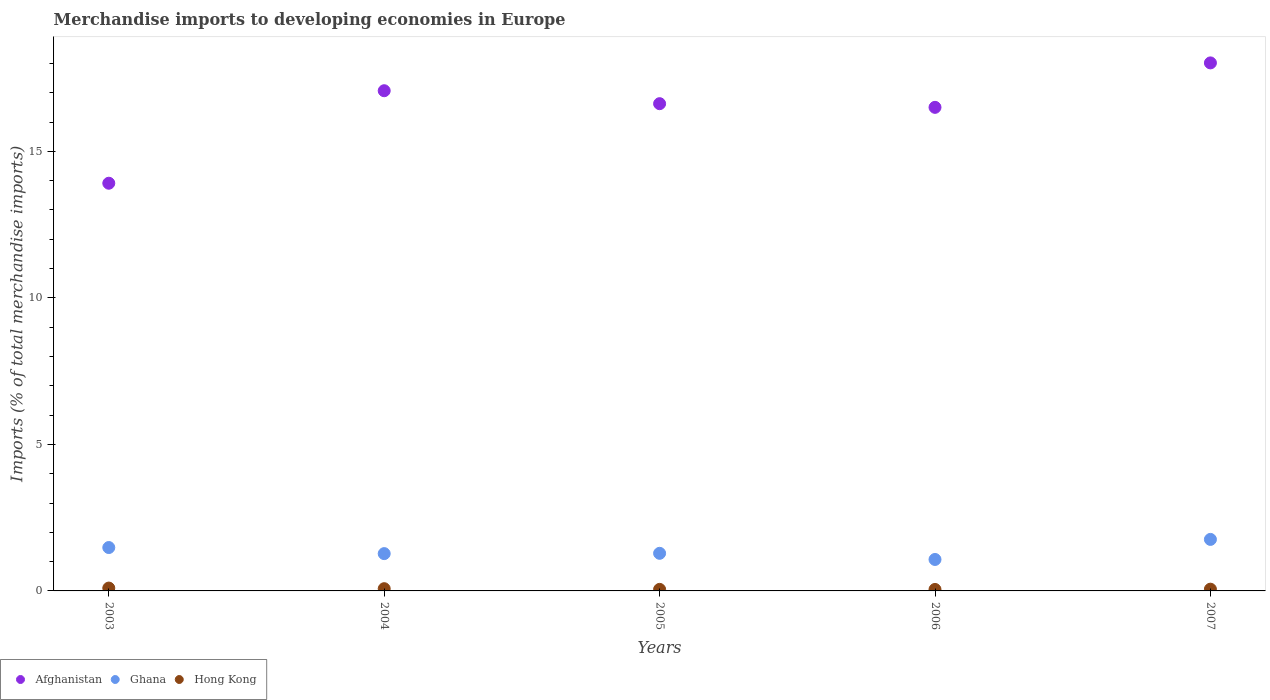Is the number of dotlines equal to the number of legend labels?
Give a very brief answer. Yes. What is the percentage total merchandise imports in Hong Kong in 2006?
Provide a succinct answer. 0.05. Across all years, what is the maximum percentage total merchandise imports in Afghanistan?
Ensure brevity in your answer.  18.02. Across all years, what is the minimum percentage total merchandise imports in Ghana?
Make the answer very short. 1.07. What is the total percentage total merchandise imports in Ghana in the graph?
Provide a succinct answer. 6.87. What is the difference between the percentage total merchandise imports in Afghanistan in 2005 and that in 2007?
Make the answer very short. -1.39. What is the difference between the percentage total merchandise imports in Afghanistan in 2006 and the percentage total merchandise imports in Hong Kong in 2003?
Ensure brevity in your answer.  16.4. What is the average percentage total merchandise imports in Hong Kong per year?
Make the answer very short. 0.07. In the year 2007, what is the difference between the percentage total merchandise imports in Hong Kong and percentage total merchandise imports in Afghanistan?
Your answer should be compact. -17.96. In how many years, is the percentage total merchandise imports in Ghana greater than 6 %?
Your response must be concise. 0. What is the ratio of the percentage total merchandise imports in Hong Kong in 2005 to that in 2007?
Ensure brevity in your answer.  0.89. Is the percentage total merchandise imports in Hong Kong in 2004 less than that in 2006?
Offer a very short reply. No. Is the difference between the percentage total merchandise imports in Hong Kong in 2005 and 2006 greater than the difference between the percentage total merchandise imports in Afghanistan in 2005 and 2006?
Offer a very short reply. No. What is the difference between the highest and the second highest percentage total merchandise imports in Ghana?
Ensure brevity in your answer.  0.28. What is the difference between the highest and the lowest percentage total merchandise imports in Afghanistan?
Provide a succinct answer. 4.11. Is the sum of the percentage total merchandise imports in Afghanistan in 2003 and 2007 greater than the maximum percentage total merchandise imports in Hong Kong across all years?
Provide a succinct answer. Yes. Is it the case that in every year, the sum of the percentage total merchandise imports in Hong Kong and percentage total merchandise imports in Afghanistan  is greater than the percentage total merchandise imports in Ghana?
Make the answer very short. Yes. Is the percentage total merchandise imports in Ghana strictly greater than the percentage total merchandise imports in Afghanistan over the years?
Your answer should be very brief. No. Is the percentage total merchandise imports in Hong Kong strictly less than the percentage total merchandise imports in Ghana over the years?
Provide a succinct answer. Yes. How many years are there in the graph?
Keep it short and to the point. 5. What is the difference between two consecutive major ticks on the Y-axis?
Offer a very short reply. 5. Are the values on the major ticks of Y-axis written in scientific E-notation?
Make the answer very short. No. Where does the legend appear in the graph?
Your answer should be very brief. Bottom left. How many legend labels are there?
Offer a terse response. 3. How are the legend labels stacked?
Offer a terse response. Horizontal. What is the title of the graph?
Your answer should be very brief. Merchandise imports to developing economies in Europe. Does "Liechtenstein" appear as one of the legend labels in the graph?
Your response must be concise. No. What is the label or title of the X-axis?
Offer a very short reply. Years. What is the label or title of the Y-axis?
Provide a short and direct response. Imports (% of total merchandise imports). What is the Imports (% of total merchandise imports) in Afghanistan in 2003?
Give a very brief answer. 13.91. What is the Imports (% of total merchandise imports) in Ghana in 2003?
Make the answer very short. 1.48. What is the Imports (% of total merchandise imports) of Hong Kong in 2003?
Provide a succinct answer. 0.1. What is the Imports (% of total merchandise imports) in Afghanistan in 2004?
Give a very brief answer. 17.07. What is the Imports (% of total merchandise imports) in Ghana in 2004?
Make the answer very short. 1.27. What is the Imports (% of total merchandise imports) in Hong Kong in 2004?
Give a very brief answer. 0.08. What is the Imports (% of total merchandise imports) in Afghanistan in 2005?
Provide a succinct answer. 16.63. What is the Imports (% of total merchandise imports) in Ghana in 2005?
Your response must be concise. 1.28. What is the Imports (% of total merchandise imports) of Hong Kong in 2005?
Your answer should be compact. 0.05. What is the Imports (% of total merchandise imports) in Afghanistan in 2006?
Offer a very short reply. 16.5. What is the Imports (% of total merchandise imports) of Ghana in 2006?
Offer a terse response. 1.07. What is the Imports (% of total merchandise imports) of Hong Kong in 2006?
Your answer should be compact. 0.05. What is the Imports (% of total merchandise imports) of Afghanistan in 2007?
Give a very brief answer. 18.02. What is the Imports (% of total merchandise imports) of Ghana in 2007?
Ensure brevity in your answer.  1.76. What is the Imports (% of total merchandise imports) of Hong Kong in 2007?
Provide a short and direct response. 0.06. Across all years, what is the maximum Imports (% of total merchandise imports) in Afghanistan?
Your answer should be very brief. 18.02. Across all years, what is the maximum Imports (% of total merchandise imports) of Ghana?
Offer a very short reply. 1.76. Across all years, what is the maximum Imports (% of total merchandise imports) in Hong Kong?
Keep it short and to the point. 0.1. Across all years, what is the minimum Imports (% of total merchandise imports) of Afghanistan?
Ensure brevity in your answer.  13.91. Across all years, what is the minimum Imports (% of total merchandise imports) in Ghana?
Your answer should be compact. 1.07. Across all years, what is the minimum Imports (% of total merchandise imports) in Hong Kong?
Your answer should be very brief. 0.05. What is the total Imports (% of total merchandise imports) of Afghanistan in the graph?
Make the answer very short. 82.13. What is the total Imports (% of total merchandise imports) in Ghana in the graph?
Make the answer very short. 6.87. What is the total Imports (% of total merchandise imports) in Hong Kong in the graph?
Your answer should be compact. 0.34. What is the difference between the Imports (% of total merchandise imports) of Afghanistan in 2003 and that in 2004?
Ensure brevity in your answer.  -3.16. What is the difference between the Imports (% of total merchandise imports) in Ghana in 2003 and that in 2004?
Keep it short and to the point. 0.21. What is the difference between the Imports (% of total merchandise imports) of Hong Kong in 2003 and that in 2004?
Provide a short and direct response. 0.02. What is the difference between the Imports (% of total merchandise imports) in Afghanistan in 2003 and that in 2005?
Offer a very short reply. -2.71. What is the difference between the Imports (% of total merchandise imports) in Ghana in 2003 and that in 2005?
Offer a very short reply. 0.2. What is the difference between the Imports (% of total merchandise imports) in Hong Kong in 2003 and that in 2005?
Make the answer very short. 0.04. What is the difference between the Imports (% of total merchandise imports) of Afghanistan in 2003 and that in 2006?
Ensure brevity in your answer.  -2.59. What is the difference between the Imports (% of total merchandise imports) in Ghana in 2003 and that in 2006?
Your answer should be very brief. 0.41. What is the difference between the Imports (% of total merchandise imports) in Hong Kong in 2003 and that in 2006?
Your answer should be compact. 0.05. What is the difference between the Imports (% of total merchandise imports) of Afghanistan in 2003 and that in 2007?
Your response must be concise. -4.11. What is the difference between the Imports (% of total merchandise imports) in Ghana in 2003 and that in 2007?
Make the answer very short. -0.28. What is the difference between the Imports (% of total merchandise imports) of Hong Kong in 2003 and that in 2007?
Give a very brief answer. 0.04. What is the difference between the Imports (% of total merchandise imports) in Afghanistan in 2004 and that in 2005?
Provide a succinct answer. 0.44. What is the difference between the Imports (% of total merchandise imports) in Ghana in 2004 and that in 2005?
Your response must be concise. -0.01. What is the difference between the Imports (% of total merchandise imports) in Hong Kong in 2004 and that in 2005?
Your answer should be very brief. 0.02. What is the difference between the Imports (% of total merchandise imports) of Afghanistan in 2004 and that in 2006?
Offer a terse response. 0.57. What is the difference between the Imports (% of total merchandise imports) of Ghana in 2004 and that in 2006?
Your answer should be compact. 0.2. What is the difference between the Imports (% of total merchandise imports) in Hong Kong in 2004 and that in 2006?
Offer a very short reply. 0.03. What is the difference between the Imports (% of total merchandise imports) of Afghanistan in 2004 and that in 2007?
Provide a succinct answer. -0.95. What is the difference between the Imports (% of total merchandise imports) in Ghana in 2004 and that in 2007?
Your response must be concise. -0.49. What is the difference between the Imports (% of total merchandise imports) in Hong Kong in 2004 and that in 2007?
Keep it short and to the point. 0.02. What is the difference between the Imports (% of total merchandise imports) in Afghanistan in 2005 and that in 2006?
Offer a terse response. 0.13. What is the difference between the Imports (% of total merchandise imports) in Ghana in 2005 and that in 2006?
Provide a short and direct response. 0.21. What is the difference between the Imports (% of total merchandise imports) in Hong Kong in 2005 and that in 2006?
Your response must be concise. 0. What is the difference between the Imports (% of total merchandise imports) of Afghanistan in 2005 and that in 2007?
Your response must be concise. -1.39. What is the difference between the Imports (% of total merchandise imports) in Ghana in 2005 and that in 2007?
Ensure brevity in your answer.  -0.47. What is the difference between the Imports (% of total merchandise imports) in Hong Kong in 2005 and that in 2007?
Offer a terse response. -0.01. What is the difference between the Imports (% of total merchandise imports) in Afghanistan in 2006 and that in 2007?
Give a very brief answer. -1.52. What is the difference between the Imports (% of total merchandise imports) of Ghana in 2006 and that in 2007?
Make the answer very short. -0.68. What is the difference between the Imports (% of total merchandise imports) in Hong Kong in 2006 and that in 2007?
Your response must be concise. -0.01. What is the difference between the Imports (% of total merchandise imports) of Afghanistan in 2003 and the Imports (% of total merchandise imports) of Ghana in 2004?
Your answer should be very brief. 12.64. What is the difference between the Imports (% of total merchandise imports) in Afghanistan in 2003 and the Imports (% of total merchandise imports) in Hong Kong in 2004?
Keep it short and to the point. 13.84. What is the difference between the Imports (% of total merchandise imports) of Ghana in 2003 and the Imports (% of total merchandise imports) of Hong Kong in 2004?
Ensure brevity in your answer.  1.4. What is the difference between the Imports (% of total merchandise imports) in Afghanistan in 2003 and the Imports (% of total merchandise imports) in Ghana in 2005?
Keep it short and to the point. 12.63. What is the difference between the Imports (% of total merchandise imports) of Afghanistan in 2003 and the Imports (% of total merchandise imports) of Hong Kong in 2005?
Offer a very short reply. 13.86. What is the difference between the Imports (% of total merchandise imports) in Ghana in 2003 and the Imports (% of total merchandise imports) in Hong Kong in 2005?
Your response must be concise. 1.43. What is the difference between the Imports (% of total merchandise imports) in Afghanistan in 2003 and the Imports (% of total merchandise imports) in Ghana in 2006?
Provide a short and direct response. 12.84. What is the difference between the Imports (% of total merchandise imports) of Afghanistan in 2003 and the Imports (% of total merchandise imports) of Hong Kong in 2006?
Offer a very short reply. 13.86. What is the difference between the Imports (% of total merchandise imports) in Ghana in 2003 and the Imports (% of total merchandise imports) in Hong Kong in 2006?
Your answer should be compact. 1.43. What is the difference between the Imports (% of total merchandise imports) in Afghanistan in 2003 and the Imports (% of total merchandise imports) in Ghana in 2007?
Your response must be concise. 12.15. What is the difference between the Imports (% of total merchandise imports) in Afghanistan in 2003 and the Imports (% of total merchandise imports) in Hong Kong in 2007?
Provide a succinct answer. 13.85. What is the difference between the Imports (% of total merchandise imports) in Ghana in 2003 and the Imports (% of total merchandise imports) in Hong Kong in 2007?
Your response must be concise. 1.42. What is the difference between the Imports (% of total merchandise imports) in Afghanistan in 2004 and the Imports (% of total merchandise imports) in Ghana in 2005?
Ensure brevity in your answer.  15.79. What is the difference between the Imports (% of total merchandise imports) in Afghanistan in 2004 and the Imports (% of total merchandise imports) in Hong Kong in 2005?
Keep it short and to the point. 17.02. What is the difference between the Imports (% of total merchandise imports) in Ghana in 2004 and the Imports (% of total merchandise imports) in Hong Kong in 2005?
Your answer should be very brief. 1.22. What is the difference between the Imports (% of total merchandise imports) in Afghanistan in 2004 and the Imports (% of total merchandise imports) in Ghana in 2006?
Give a very brief answer. 16. What is the difference between the Imports (% of total merchandise imports) of Afghanistan in 2004 and the Imports (% of total merchandise imports) of Hong Kong in 2006?
Make the answer very short. 17.02. What is the difference between the Imports (% of total merchandise imports) in Ghana in 2004 and the Imports (% of total merchandise imports) in Hong Kong in 2006?
Offer a very short reply. 1.22. What is the difference between the Imports (% of total merchandise imports) of Afghanistan in 2004 and the Imports (% of total merchandise imports) of Ghana in 2007?
Your answer should be very brief. 15.31. What is the difference between the Imports (% of total merchandise imports) in Afghanistan in 2004 and the Imports (% of total merchandise imports) in Hong Kong in 2007?
Ensure brevity in your answer.  17.01. What is the difference between the Imports (% of total merchandise imports) in Ghana in 2004 and the Imports (% of total merchandise imports) in Hong Kong in 2007?
Offer a very short reply. 1.21. What is the difference between the Imports (% of total merchandise imports) of Afghanistan in 2005 and the Imports (% of total merchandise imports) of Ghana in 2006?
Ensure brevity in your answer.  15.55. What is the difference between the Imports (% of total merchandise imports) of Afghanistan in 2005 and the Imports (% of total merchandise imports) of Hong Kong in 2006?
Offer a terse response. 16.58. What is the difference between the Imports (% of total merchandise imports) in Ghana in 2005 and the Imports (% of total merchandise imports) in Hong Kong in 2006?
Make the answer very short. 1.23. What is the difference between the Imports (% of total merchandise imports) in Afghanistan in 2005 and the Imports (% of total merchandise imports) in Ghana in 2007?
Provide a short and direct response. 14.87. What is the difference between the Imports (% of total merchandise imports) in Afghanistan in 2005 and the Imports (% of total merchandise imports) in Hong Kong in 2007?
Provide a short and direct response. 16.57. What is the difference between the Imports (% of total merchandise imports) in Ghana in 2005 and the Imports (% of total merchandise imports) in Hong Kong in 2007?
Your response must be concise. 1.22. What is the difference between the Imports (% of total merchandise imports) in Afghanistan in 2006 and the Imports (% of total merchandise imports) in Ghana in 2007?
Provide a succinct answer. 14.74. What is the difference between the Imports (% of total merchandise imports) in Afghanistan in 2006 and the Imports (% of total merchandise imports) in Hong Kong in 2007?
Make the answer very short. 16.44. What is the difference between the Imports (% of total merchandise imports) of Ghana in 2006 and the Imports (% of total merchandise imports) of Hong Kong in 2007?
Make the answer very short. 1.01. What is the average Imports (% of total merchandise imports) of Afghanistan per year?
Give a very brief answer. 16.43. What is the average Imports (% of total merchandise imports) of Ghana per year?
Ensure brevity in your answer.  1.37. What is the average Imports (% of total merchandise imports) of Hong Kong per year?
Give a very brief answer. 0.07. In the year 2003, what is the difference between the Imports (% of total merchandise imports) of Afghanistan and Imports (% of total merchandise imports) of Ghana?
Your response must be concise. 12.43. In the year 2003, what is the difference between the Imports (% of total merchandise imports) of Afghanistan and Imports (% of total merchandise imports) of Hong Kong?
Your answer should be compact. 13.81. In the year 2003, what is the difference between the Imports (% of total merchandise imports) of Ghana and Imports (% of total merchandise imports) of Hong Kong?
Your answer should be compact. 1.38. In the year 2004, what is the difference between the Imports (% of total merchandise imports) in Afghanistan and Imports (% of total merchandise imports) in Ghana?
Provide a short and direct response. 15.8. In the year 2004, what is the difference between the Imports (% of total merchandise imports) of Afghanistan and Imports (% of total merchandise imports) of Hong Kong?
Give a very brief answer. 16.99. In the year 2004, what is the difference between the Imports (% of total merchandise imports) of Ghana and Imports (% of total merchandise imports) of Hong Kong?
Your response must be concise. 1.2. In the year 2005, what is the difference between the Imports (% of total merchandise imports) in Afghanistan and Imports (% of total merchandise imports) in Ghana?
Ensure brevity in your answer.  15.34. In the year 2005, what is the difference between the Imports (% of total merchandise imports) of Afghanistan and Imports (% of total merchandise imports) of Hong Kong?
Keep it short and to the point. 16.57. In the year 2005, what is the difference between the Imports (% of total merchandise imports) in Ghana and Imports (% of total merchandise imports) in Hong Kong?
Give a very brief answer. 1.23. In the year 2006, what is the difference between the Imports (% of total merchandise imports) of Afghanistan and Imports (% of total merchandise imports) of Ghana?
Give a very brief answer. 15.43. In the year 2006, what is the difference between the Imports (% of total merchandise imports) in Afghanistan and Imports (% of total merchandise imports) in Hong Kong?
Your answer should be compact. 16.45. In the year 2006, what is the difference between the Imports (% of total merchandise imports) of Ghana and Imports (% of total merchandise imports) of Hong Kong?
Your answer should be compact. 1.02. In the year 2007, what is the difference between the Imports (% of total merchandise imports) of Afghanistan and Imports (% of total merchandise imports) of Ghana?
Ensure brevity in your answer.  16.26. In the year 2007, what is the difference between the Imports (% of total merchandise imports) in Afghanistan and Imports (% of total merchandise imports) in Hong Kong?
Your response must be concise. 17.96. In the year 2007, what is the difference between the Imports (% of total merchandise imports) in Ghana and Imports (% of total merchandise imports) in Hong Kong?
Ensure brevity in your answer.  1.7. What is the ratio of the Imports (% of total merchandise imports) of Afghanistan in 2003 to that in 2004?
Offer a terse response. 0.82. What is the ratio of the Imports (% of total merchandise imports) of Ghana in 2003 to that in 2004?
Ensure brevity in your answer.  1.16. What is the ratio of the Imports (% of total merchandise imports) of Hong Kong in 2003 to that in 2004?
Your response must be concise. 1.28. What is the ratio of the Imports (% of total merchandise imports) of Afghanistan in 2003 to that in 2005?
Your response must be concise. 0.84. What is the ratio of the Imports (% of total merchandise imports) of Ghana in 2003 to that in 2005?
Give a very brief answer. 1.15. What is the ratio of the Imports (% of total merchandise imports) of Hong Kong in 2003 to that in 2005?
Keep it short and to the point. 1.85. What is the ratio of the Imports (% of total merchandise imports) of Afghanistan in 2003 to that in 2006?
Keep it short and to the point. 0.84. What is the ratio of the Imports (% of total merchandise imports) in Ghana in 2003 to that in 2006?
Offer a very short reply. 1.38. What is the ratio of the Imports (% of total merchandise imports) in Hong Kong in 2003 to that in 2006?
Your answer should be very brief. 1.94. What is the ratio of the Imports (% of total merchandise imports) of Afghanistan in 2003 to that in 2007?
Your answer should be compact. 0.77. What is the ratio of the Imports (% of total merchandise imports) in Ghana in 2003 to that in 2007?
Give a very brief answer. 0.84. What is the ratio of the Imports (% of total merchandise imports) of Hong Kong in 2003 to that in 2007?
Offer a very short reply. 1.63. What is the ratio of the Imports (% of total merchandise imports) of Afghanistan in 2004 to that in 2005?
Provide a succinct answer. 1.03. What is the ratio of the Imports (% of total merchandise imports) in Hong Kong in 2004 to that in 2005?
Your answer should be very brief. 1.45. What is the ratio of the Imports (% of total merchandise imports) of Afghanistan in 2004 to that in 2006?
Ensure brevity in your answer.  1.03. What is the ratio of the Imports (% of total merchandise imports) in Ghana in 2004 to that in 2006?
Your answer should be very brief. 1.19. What is the ratio of the Imports (% of total merchandise imports) of Hong Kong in 2004 to that in 2006?
Ensure brevity in your answer.  1.52. What is the ratio of the Imports (% of total merchandise imports) of Afghanistan in 2004 to that in 2007?
Offer a very short reply. 0.95. What is the ratio of the Imports (% of total merchandise imports) in Ghana in 2004 to that in 2007?
Your response must be concise. 0.72. What is the ratio of the Imports (% of total merchandise imports) in Hong Kong in 2004 to that in 2007?
Keep it short and to the point. 1.28. What is the ratio of the Imports (% of total merchandise imports) of Afghanistan in 2005 to that in 2006?
Provide a short and direct response. 1.01. What is the ratio of the Imports (% of total merchandise imports) of Ghana in 2005 to that in 2006?
Keep it short and to the point. 1.2. What is the ratio of the Imports (% of total merchandise imports) of Hong Kong in 2005 to that in 2006?
Provide a short and direct response. 1.05. What is the ratio of the Imports (% of total merchandise imports) in Afghanistan in 2005 to that in 2007?
Offer a very short reply. 0.92. What is the ratio of the Imports (% of total merchandise imports) in Ghana in 2005 to that in 2007?
Your answer should be very brief. 0.73. What is the ratio of the Imports (% of total merchandise imports) in Hong Kong in 2005 to that in 2007?
Offer a very short reply. 0.89. What is the ratio of the Imports (% of total merchandise imports) in Afghanistan in 2006 to that in 2007?
Give a very brief answer. 0.92. What is the ratio of the Imports (% of total merchandise imports) in Ghana in 2006 to that in 2007?
Your answer should be compact. 0.61. What is the ratio of the Imports (% of total merchandise imports) of Hong Kong in 2006 to that in 2007?
Provide a succinct answer. 0.84. What is the difference between the highest and the second highest Imports (% of total merchandise imports) in Afghanistan?
Your answer should be compact. 0.95. What is the difference between the highest and the second highest Imports (% of total merchandise imports) in Ghana?
Make the answer very short. 0.28. What is the difference between the highest and the second highest Imports (% of total merchandise imports) of Hong Kong?
Your answer should be compact. 0.02. What is the difference between the highest and the lowest Imports (% of total merchandise imports) of Afghanistan?
Give a very brief answer. 4.11. What is the difference between the highest and the lowest Imports (% of total merchandise imports) of Ghana?
Provide a short and direct response. 0.68. What is the difference between the highest and the lowest Imports (% of total merchandise imports) in Hong Kong?
Your response must be concise. 0.05. 